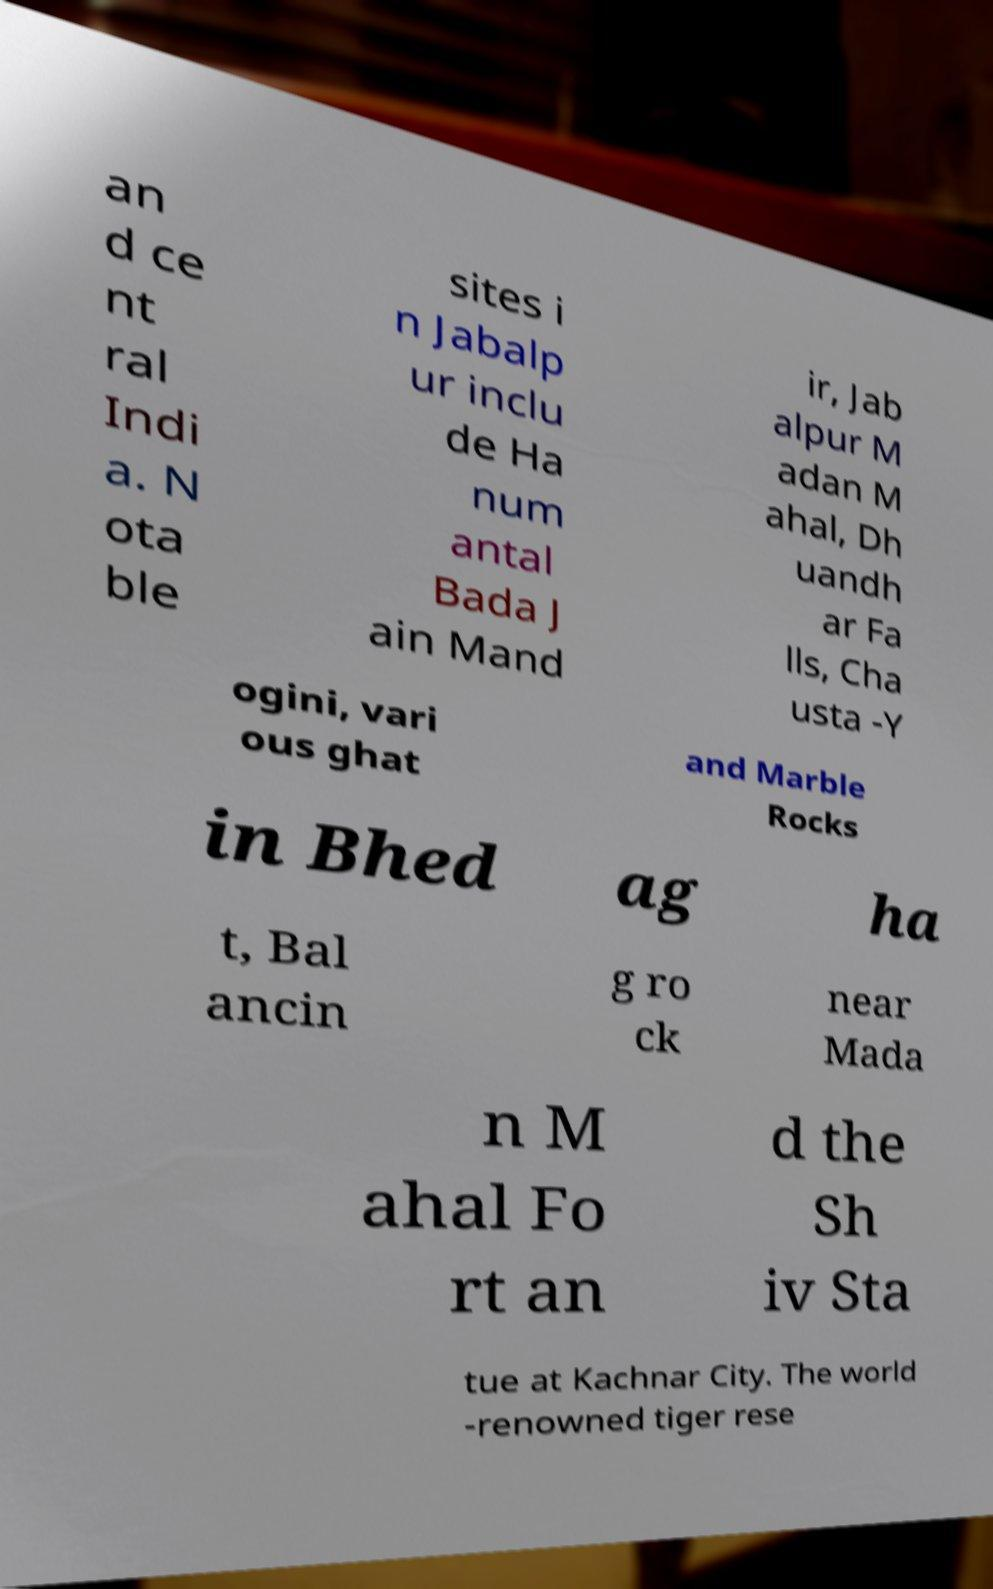Could you extract and type out the text from this image? an d ce nt ral Indi a. N ota ble sites i n Jabalp ur inclu de Ha num antal Bada J ain Mand ir, Jab alpur M adan M ahal, Dh uandh ar Fa lls, Cha usta -Y ogini, vari ous ghat and Marble Rocks in Bhed ag ha t, Bal ancin g ro ck near Mada n M ahal Fo rt an d the Sh iv Sta tue at Kachnar City. The world -renowned tiger rese 